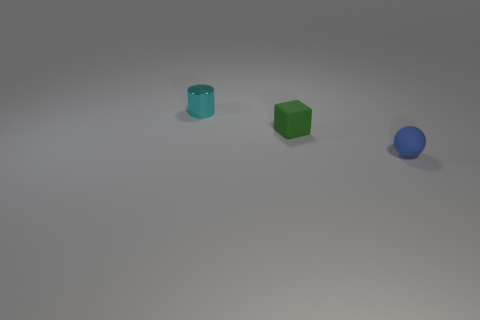Are there any other things that are the same material as the cyan cylinder?
Make the answer very short. No. Is the shape of the matte object that is in front of the small rubber cube the same as  the small metal thing?
Provide a succinct answer. No. There is a tiny rubber thing that is on the left side of the small rubber thing in front of the block; how many objects are behind it?
Offer a very short reply. 1. Are there any other things that are the same shape as the cyan object?
Ensure brevity in your answer.  No. How many objects are either yellow rubber spheres or matte spheres?
Ensure brevity in your answer.  1. There is a rubber thing that is behind the blue rubber sphere; what is its shape?
Provide a short and direct response. Cube. Is the size of the rubber thing that is to the right of the matte block the same as the rubber block?
Provide a short and direct response. Yes. There is a object that is both in front of the small cyan metallic cylinder and to the left of the small sphere; what is its size?
Provide a succinct answer. Small. Are there an equal number of small cyan cylinders behind the blue rubber object and small cyan objects?
Offer a very short reply. Yes. The tiny matte cube has what color?
Offer a very short reply. Green. 